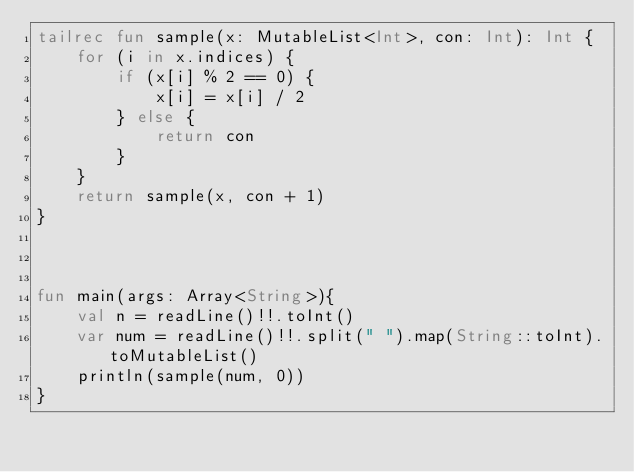<code> <loc_0><loc_0><loc_500><loc_500><_Kotlin_>tailrec fun sample(x: MutableList<Int>, con: Int): Int {
    for (i in x.indices) {
        if (x[i] % 2 == 0) {
            x[i] = x[i] / 2
        } else {
            return con
        }
    }
    return sample(x, con + 1)
}



fun main(args: Array<String>){
    val n = readLine()!!.toInt()
    var num = readLine()!!.split(" ").map(String::toInt).toMutableList()
    println(sample(num, 0))
}
</code> 